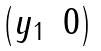Convert formula to latex. <formula><loc_0><loc_0><loc_500><loc_500>\begin{pmatrix} y _ { 1 } & 0 \end{pmatrix}</formula> 